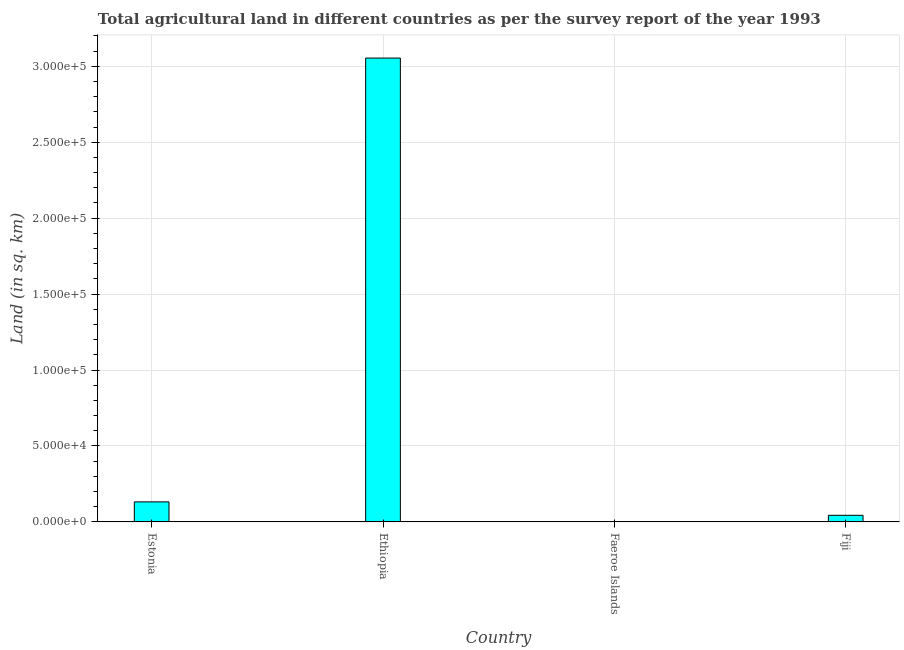What is the title of the graph?
Make the answer very short. Total agricultural land in different countries as per the survey report of the year 1993. What is the label or title of the Y-axis?
Offer a very short reply. Land (in sq. km). What is the agricultural land in Fiji?
Make the answer very short. 4350. Across all countries, what is the maximum agricultural land?
Provide a short and direct response. 3.05e+05. In which country was the agricultural land maximum?
Make the answer very short. Ethiopia. In which country was the agricultural land minimum?
Ensure brevity in your answer.  Faeroe Islands. What is the sum of the agricultural land?
Your answer should be very brief. 3.23e+05. What is the difference between the agricultural land in Estonia and Faeroe Islands?
Make the answer very short. 1.32e+04. What is the average agricultural land per country?
Offer a terse response. 8.07e+04. What is the median agricultural land?
Keep it short and to the point. 8775. What is the ratio of the agricultural land in Estonia to that in Faeroe Islands?
Offer a terse response. 440. Is the difference between the agricultural land in Estonia and Faeroe Islands greater than the difference between any two countries?
Keep it short and to the point. No. What is the difference between the highest and the second highest agricultural land?
Give a very brief answer. 2.92e+05. What is the difference between the highest and the lowest agricultural land?
Give a very brief answer. 3.05e+05. Are all the bars in the graph horizontal?
Offer a terse response. No. What is the difference between two consecutive major ticks on the Y-axis?
Give a very brief answer. 5.00e+04. Are the values on the major ticks of Y-axis written in scientific E-notation?
Offer a very short reply. Yes. What is the Land (in sq. km) of Estonia?
Offer a terse response. 1.32e+04. What is the Land (in sq. km) of Ethiopia?
Your answer should be very brief. 3.05e+05. What is the Land (in sq. km) of Faeroe Islands?
Make the answer very short. 30. What is the Land (in sq. km) of Fiji?
Offer a very short reply. 4350. What is the difference between the Land (in sq. km) in Estonia and Ethiopia?
Keep it short and to the point. -2.92e+05. What is the difference between the Land (in sq. km) in Estonia and Faeroe Islands?
Provide a short and direct response. 1.32e+04. What is the difference between the Land (in sq. km) in Estonia and Fiji?
Your response must be concise. 8850. What is the difference between the Land (in sq. km) in Ethiopia and Faeroe Islands?
Your answer should be very brief. 3.05e+05. What is the difference between the Land (in sq. km) in Ethiopia and Fiji?
Offer a terse response. 3.01e+05. What is the difference between the Land (in sq. km) in Faeroe Islands and Fiji?
Offer a terse response. -4320. What is the ratio of the Land (in sq. km) in Estonia to that in Ethiopia?
Provide a succinct answer. 0.04. What is the ratio of the Land (in sq. km) in Estonia to that in Faeroe Islands?
Provide a succinct answer. 440. What is the ratio of the Land (in sq. km) in Estonia to that in Fiji?
Provide a succinct answer. 3.03. What is the ratio of the Land (in sq. km) in Ethiopia to that in Faeroe Islands?
Offer a terse response. 1.02e+04. What is the ratio of the Land (in sq. km) in Ethiopia to that in Fiji?
Provide a succinct answer. 70.21. What is the ratio of the Land (in sq. km) in Faeroe Islands to that in Fiji?
Your answer should be very brief. 0.01. 